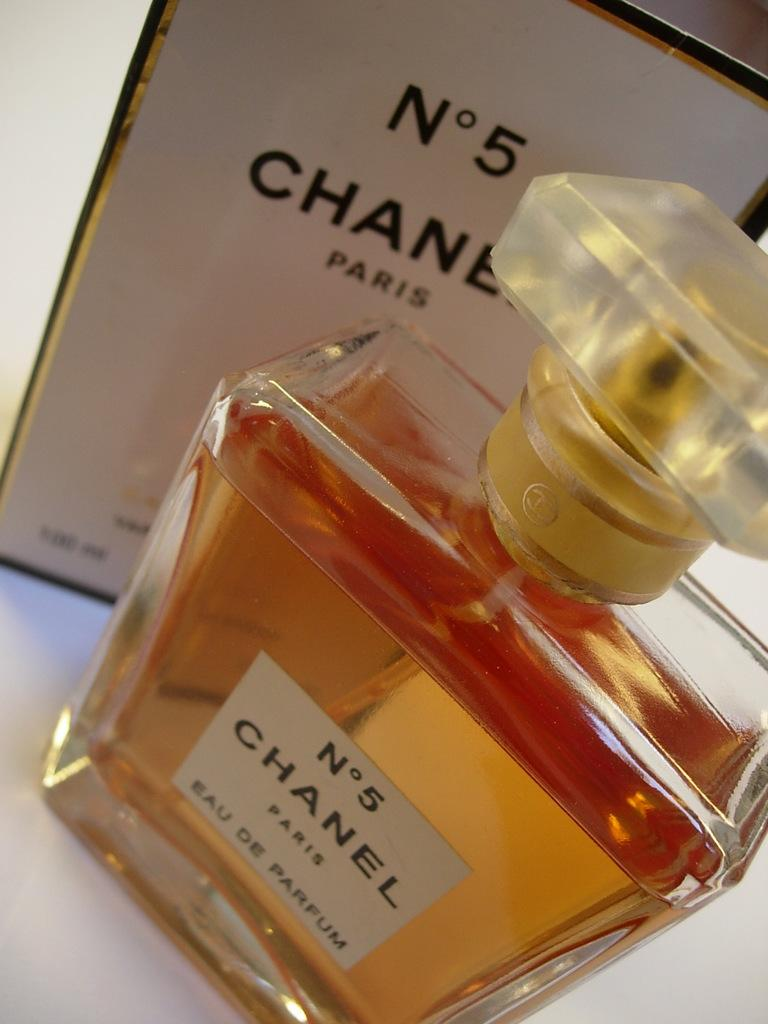What object is the main focus of the image? There is a perfume bottle in the image. What is inside the perfume bottle? The perfume bottle contains liquid. How can the perfume be identified? There is a label on the perfume bottle. What else is visible in the image besides the perfume bottle? There is a frame with writing behind the perfume bottle. How many trucks are visible in the image? There are no trucks present in the image. Is the perfume bottle surrounded by snow in the image? There is no snow present in the image. 